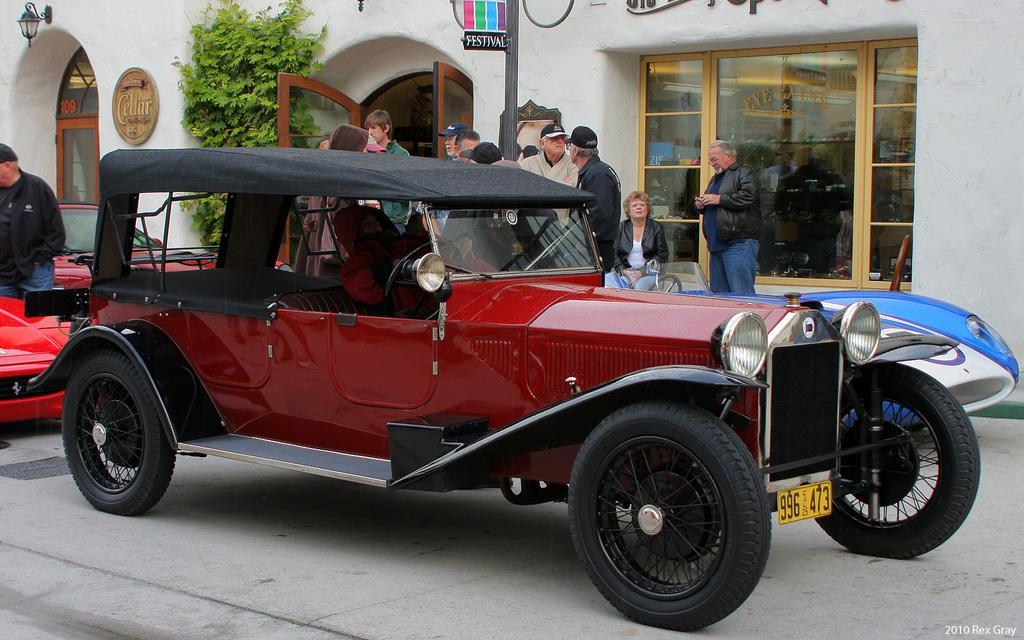How would you summarize this image in a sentence or two? In front of the image there are vehicles on the road. Behind the vehicles there are people. There is a person sitting on the chair. There is a door. There are glass windows. There is a tree, pole. There is a lamp and some object on the wall. There is some text at the bottom of the image. 